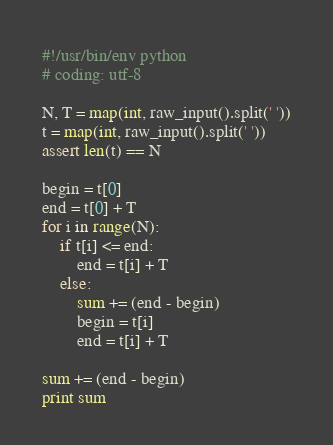<code> <loc_0><loc_0><loc_500><loc_500><_Python_>#!/usr/bin/env python
# coding: utf-8

N, T = map(int, raw_input().split(' '))
t = map(int, raw_input().split(' '))
assert len(t) == N

begin = t[0]
end = t[0] + T
for i in range(N):
    if t[i] <= end:
        end = t[i] + T
    else:
        sum += (end - begin)
        begin = t[i]
        end = t[i] + T

sum += (end - begin)
print sum
</code> 